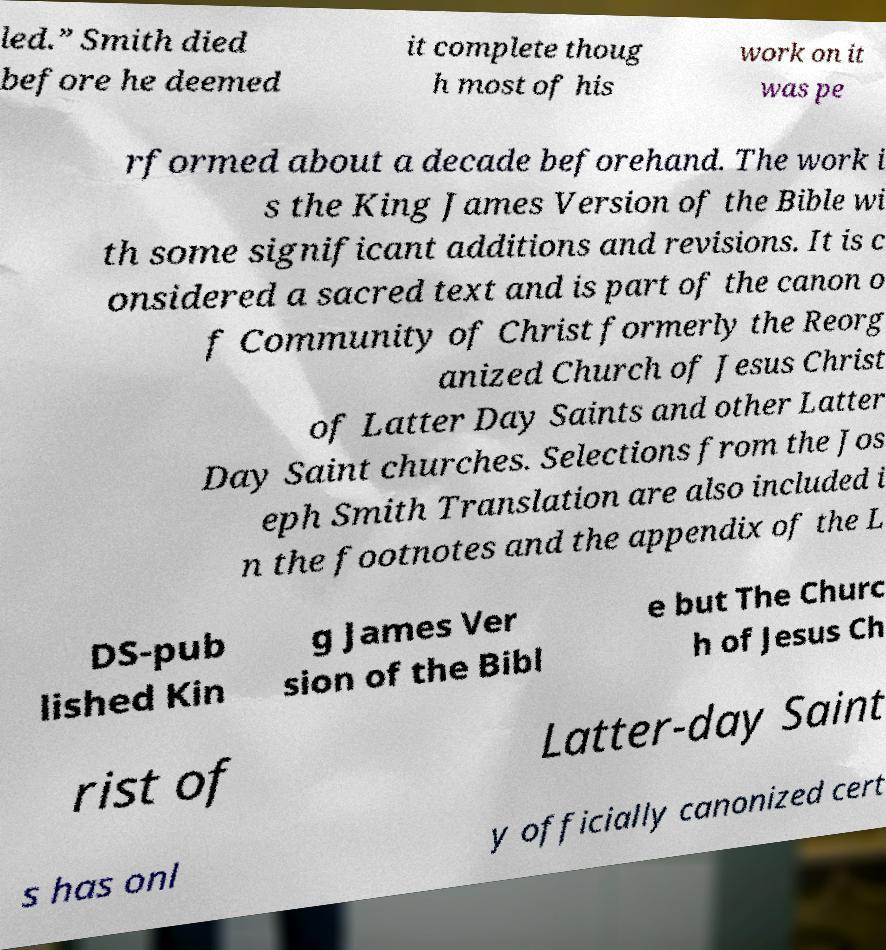Please identify and transcribe the text found in this image. led.” Smith died before he deemed it complete thoug h most of his work on it was pe rformed about a decade beforehand. The work i s the King James Version of the Bible wi th some significant additions and revisions. It is c onsidered a sacred text and is part of the canon o f Community of Christ formerly the Reorg anized Church of Jesus Christ of Latter Day Saints and other Latter Day Saint churches. Selections from the Jos eph Smith Translation are also included i n the footnotes and the appendix of the L DS-pub lished Kin g James Ver sion of the Bibl e but The Churc h of Jesus Ch rist of Latter-day Saint s has onl y officially canonized cert 